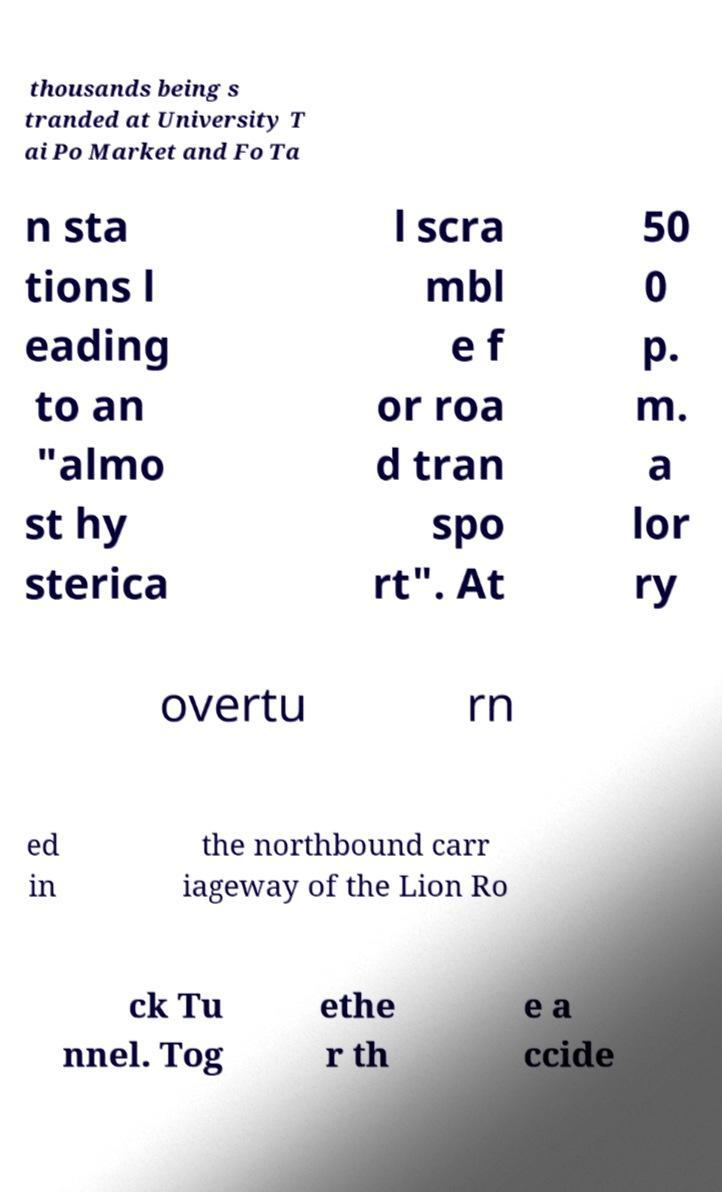Could you extract and type out the text from this image? thousands being s tranded at University T ai Po Market and Fo Ta n sta tions l eading to an "almo st hy sterica l scra mbl e f or roa d tran spo rt". At 50 0 p. m. a lor ry overtu rn ed in the northbound carr iageway of the Lion Ro ck Tu nnel. Tog ethe r th e a ccide 